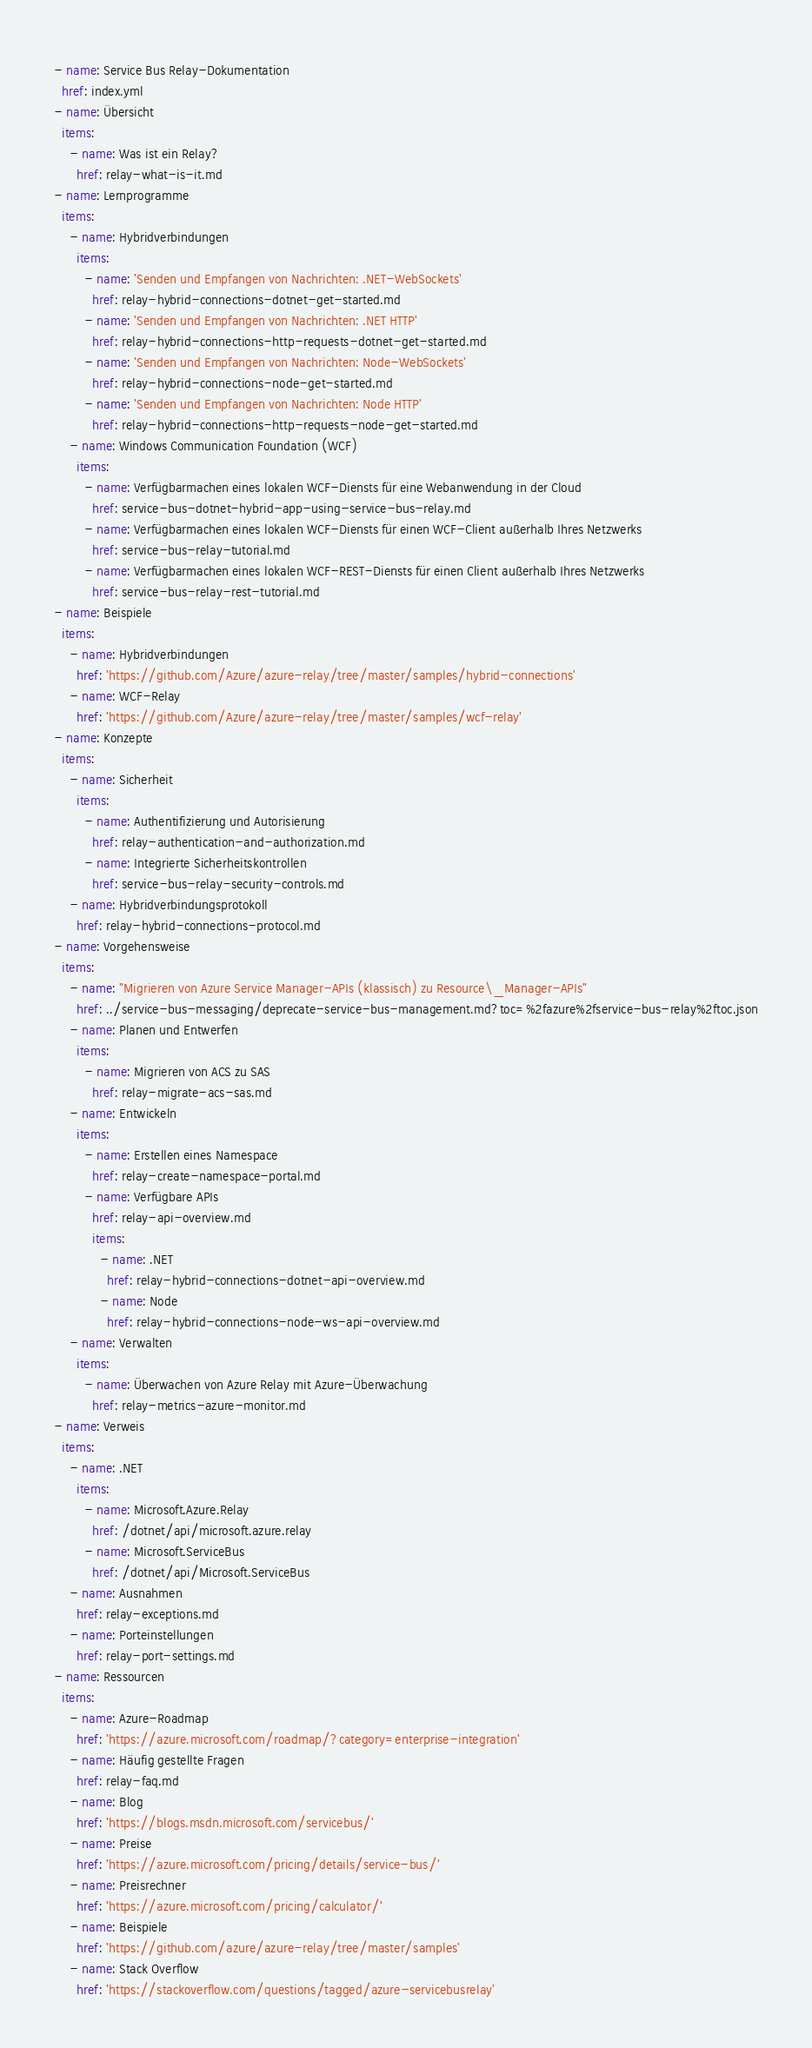<code> <loc_0><loc_0><loc_500><loc_500><_YAML_>- name: Service Bus Relay-Dokumentation
  href: index.yml
- name: Übersicht
  items:
    - name: Was ist ein Relay?
      href: relay-what-is-it.md
- name: Lernprogramme
  items:
    - name: Hybridverbindungen
      items:
        - name: 'Senden und Empfangen von Nachrichten: .NET-WebSockets'
          href: relay-hybrid-connections-dotnet-get-started.md
        - name: 'Senden und Empfangen von Nachrichten: .NET HTTP'
          href: relay-hybrid-connections-http-requests-dotnet-get-started.md
        - name: 'Senden und Empfangen von Nachrichten: Node-WebSockets'
          href: relay-hybrid-connections-node-get-started.md
        - name: 'Senden und Empfangen von Nachrichten: Node HTTP'
          href: relay-hybrid-connections-http-requests-node-get-started.md
    - name: Windows Communication Foundation (WCF)
      items:
        - name: Verfügbarmachen eines lokalen WCF-Diensts für eine Webanwendung in der Cloud
          href: service-bus-dotnet-hybrid-app-using-service-bus-relay.md
        - name: Verfügbarmachen eines lokalen WCF-Diensts für einen WCF-Client außerhalb Ihres Netzwerks
          href: service-bus-relay-tutorial.md
        - name: Verfügbarmachen eines lokalen WCF-REST-Diensts für einen Client außerhalb Ihres Netzwerks
          href: service-bus-relay-rest-tutorial.md
- name: Beispiele
  items:
    - name: Hybridverbindungen
      href: 'https://github.com/Azure/azure-relay/tree/master/samples/hybrid-connections'
    - name: WCF-Relay
      href: 'https://github.com/Azure/azure-relay/tree/master/samples/wcf-relay'
- name: Konzepte
  items:
    - name: Sicherheit
      items:
        - name: Authentifizierung und Autorisierung
          href: relay-authentication-and-authorization.md
        - name: Integrierte Sicherheitskontrollen
          href: service-bus-relay-security-controls.md
    - name: Hybridverbindungsprotokoll
      href: relay-hybrid-connections-protocol.md
- name: Vorgehensweise
  items:
    - name: "Migrieren von Azure Service Manager-APIs (klassisch) zu Resource\_Manager-APIs"
      href: ../service-bus-messaging/deprecate-service-bus-management.md?toc=%2fazure%2fservice-bus-relay%2ftoc.json
    - name: Planen und Entwerfen
      items:
        - name: Migrieren von ACS zu SAS
          href: relay-migrate-acs-sas.md
    - name: Entwickeln
      items:
        - name: Erstellen eines Namespace
          href: relay-create-namespace-portal.md
        - name: Verfügbare APIs
          href: relay-api-overview.md
          items:
            - name: .NET
              href: relay-hybrid-connections-dotnet-api-overview.md
            - name: Node
              href: relay-hybrid-connections-node-ws-api-overview.md
    - name: Verwalten
      items:
        - name: Überwachen von Azure Relay mit Azure-Überwachung
          href: relay-metrics-azure-monitor.md
- name: Verweis
  items:
    - name: .NET
      items:
        - name: Microsoft.Azure.Relay
          href: /dotnet/api/microsoft.azure.relay
        - name: Microsoft.ServiceBus
          href: /dotnet/api/Microsoft.ServiceBus
    - name: Ausnahmen
      href: relay-exceptions.md
    - name: Porteinstellungen
      href: relay-port-settings.md
- name: Ressourcen
  items:
    - name: Azure-Roadmap
      href: 'https://azure.microsoft.com/roadmap/?category=enterprise-integration'
    - name: Häufig gestellte Fragen
      href: relay-faq.md
    - name: Blog
      href: 'https://blogs.msdn.microsoft.com/servicebus/'
    - name: Preise
      href: 'https://azure.microsoft.com/pricing/details/service-bus/'
    - name: Preisrechner
      href: 'https://azure.microsoft.com/pricing/calculator/'
    - name: Beispiele
      href: 'https://github.com/azure/azure-relay/tree/master/samples'
    - name: Stack Overflow
      href: 'https://stackoverflow.com/questions/tagged/azure-servicebusrelay'</code> 